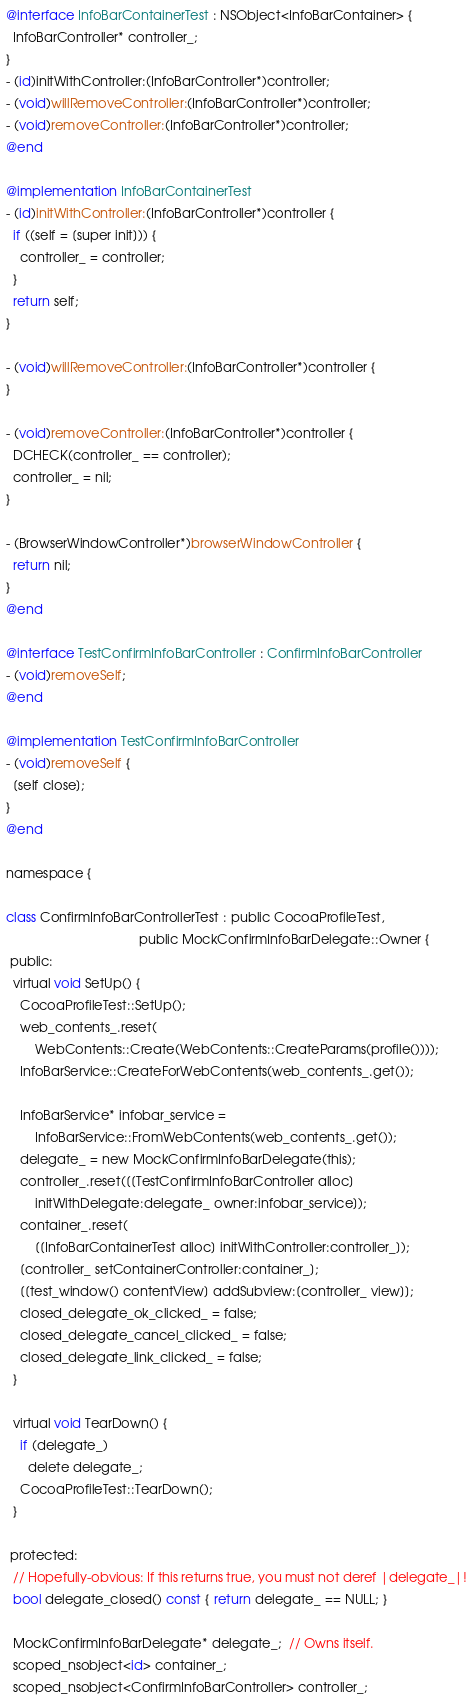Convert code to text. <code><loc_0><loc_0><loc_500><loc_500><_ObjectiveC_>

@interface InfoBarContainerTest : NSObject<InfoBarContainer> {
  InfoBarController* controller_;
}
- (id)initWithController:(InfoBarController*)controller;
- (void)willRemoveController:(InfoBarController*)controller;
- (void)removeController:(InfoBarController*)controller;
@end

@implementation InfoBarContainerTest
- (id)initWithController:(InfoBarController*)controller {
  if ((self = [super init])) {
    controller_ = controller;
  }
  return self;
}

- (void)willRemoveController:(InfoBarController*)controller {
}

- (void)removeController:(InfoBarController*)controller {
  DCHECK(controller_ == controller);
  controller_ = nil;
}

- (BrowserWindowController*)browserWindowController {
  return nil;
}
@end

@interface TestConfirmInfoBarController : ConfirmInfoBarController
- (void)removeSelf;
@end

@implementation TestConfirmInfoBarController
- (void)removeSelf {
  [self close];
}
@end

namespace {

class ConfirmInfoBarControllerTest : public CocoaProfileTest,
                                     public MockConfirmInfoBarDelegate::Owner {
 public:
  virtual void SetUp() {
    CocoaProfileTest::SetUp();
    web_contents_.reset(
        WebContents::Create(WebContents::CreateParams(profile())));
    InfoBarService::CreateForWebContents(web_contents_.get());

    InfoBarService* infobar_service =
        InfoBarService::FromWebContents(web_contents_.get());
    delegate_ = new MockConfirmInfoBarDelegate(this);
    controller_.reset([[TestConfirmInfoBarController alloc]
        initWithDelegate:delegate_ owner:infobar_service]);
    container_.reset(
        [[InfoBarContainerTest alloc] initWithController:controller_]);
    [controller_ setContainerController:container_];
    [[test_window() contentView] addSubview:[controller_ view]];
    closed_delegate_ok_clicked_ = false;
    closed_delegate_cancel_clicked_ = false;
    closed_delegate_link_clicked_ = false;
  }

  virtual void TearDown() {
    if (delegate_)
      delete delegate_;
    CocoaProfileTest::TearDown();
  }

 protected:
  // Hopefully-obvious: If this returns true, you must not deref |delegate_|!
  bool delegate_closed() const { return delegate_ == NULL; }

  MockConfirmInfoBarDelegate* delegate_;  // Owns itself.
  scoped_nsobject<id> container_;
  scoped_nsobject<ConfirmInfoBarController> controller_;</code> 